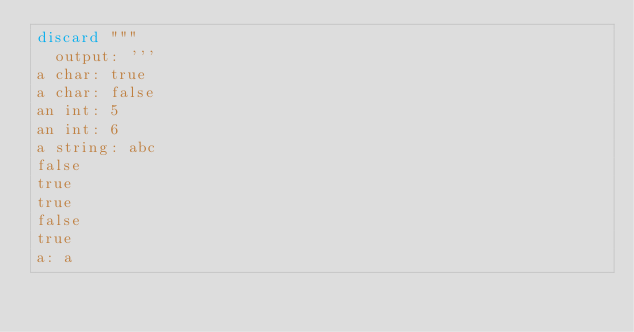<code> <loc_0><loc_0><loc_500><loc_500><_Nim_>discard """
  output: '''
a char: true
a char: false
an int: 5
an int: 6
a string: abc
false
true
true
false
true
a: a</code> 